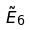<formula> <loc_0><loc_0><loc_500><loc_500>\tilde { E } _ { 6 }</formula> 